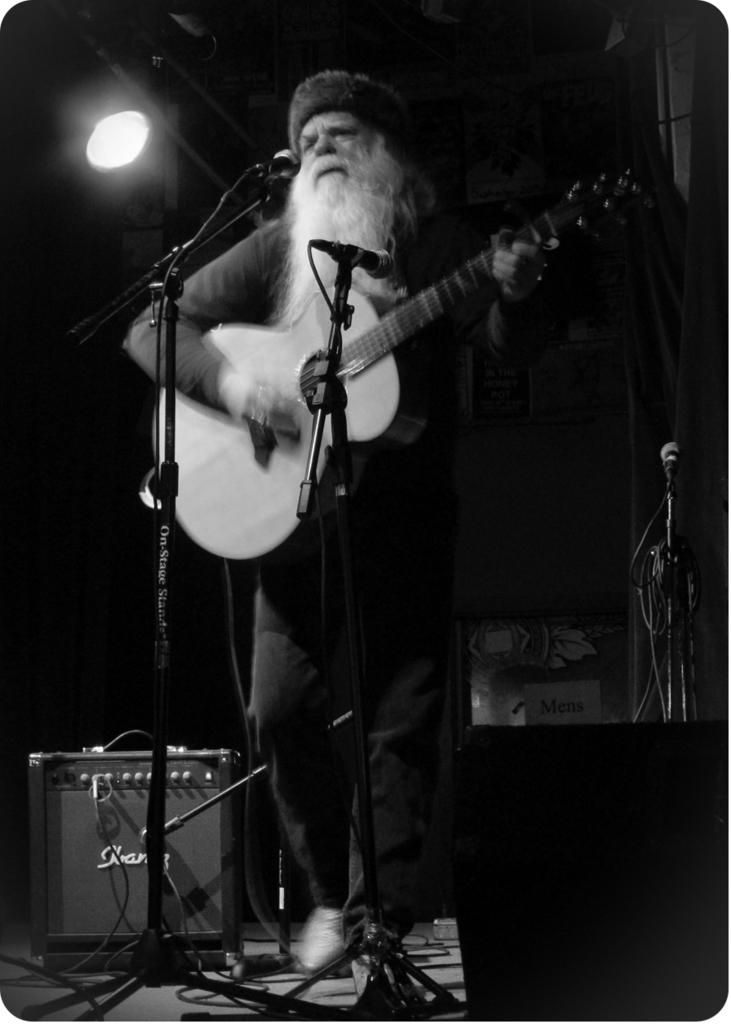What can be seen in the image that provides light? There is a light in the image. What objects are present for amplifying sound? There are two microphones in the image. What instrument is the man holding in the image? The man is holding a guitar in the image. What type of stone is being used as a cheese grater in the image? There is no stone or cheese grater present in the image. What emotion is the man expressing in the image? The image does not convey any specific emotion, and we cannot determine the man's feelings based on the provided facts. 